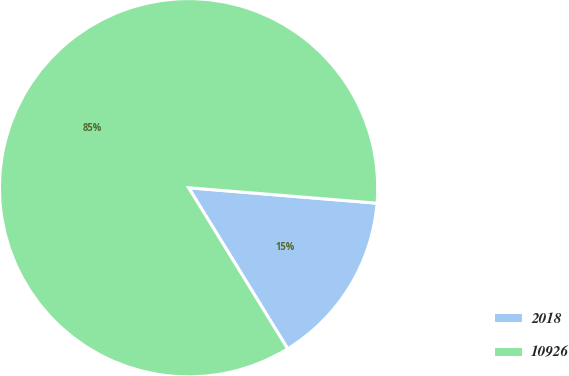Convert chart. <chart><loc_0><loc_0><loc_500><loc_500><pie_chart><fcel>2018<fcel>10926<nl><fcel>14.92%<fcel>85.08%<nl></chart> 